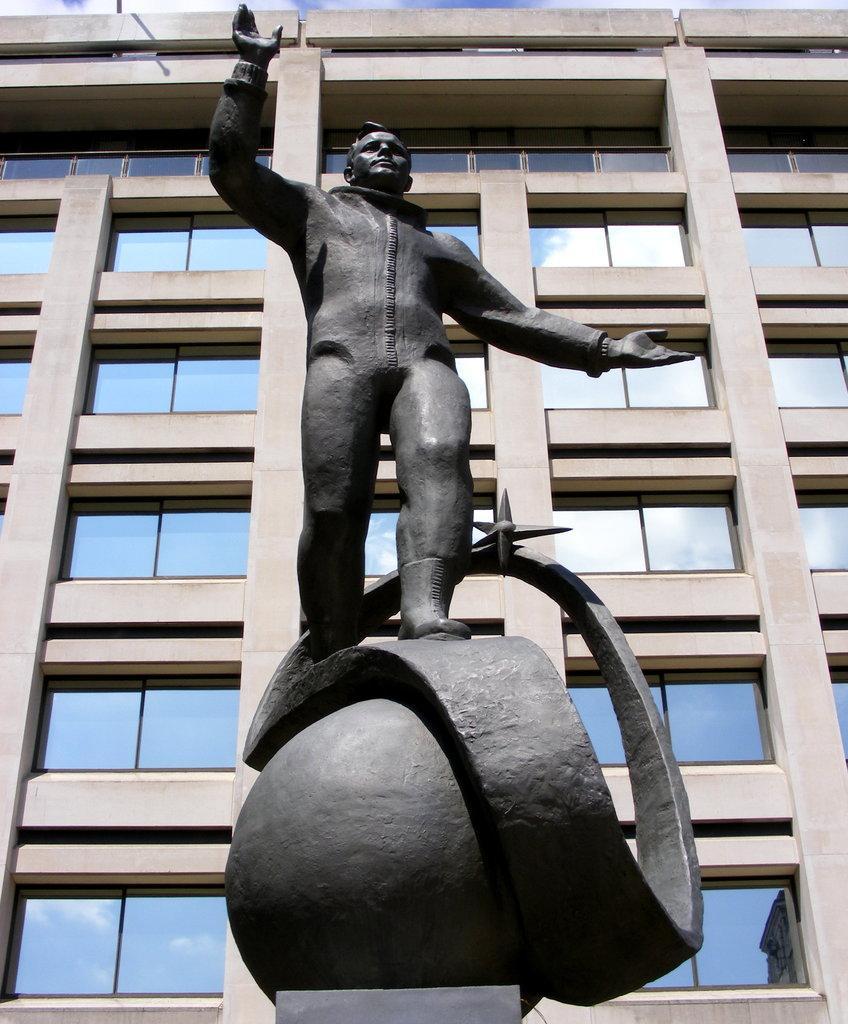Could you give a brief overview of what you see in this image? In this image there is a sculpture. Behind the sculpture there is a building. There are glass windows to the building. At the extreme top there is the sky. 